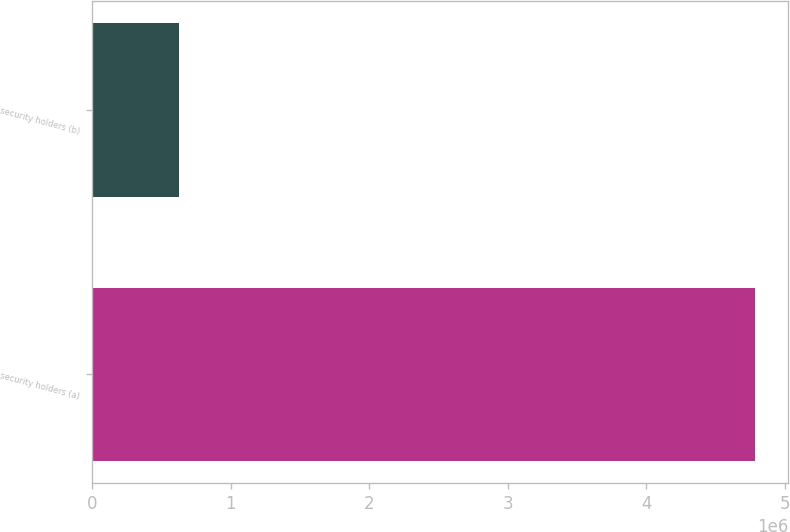Convert chart. <chart><loc_0><loc_0><loc_500><loc_500><bar_chart><fcel>security holders (a)<fcel>security holders (b)<nl><fcel>4.78704e+06<fcel>628328<nl></chart> 